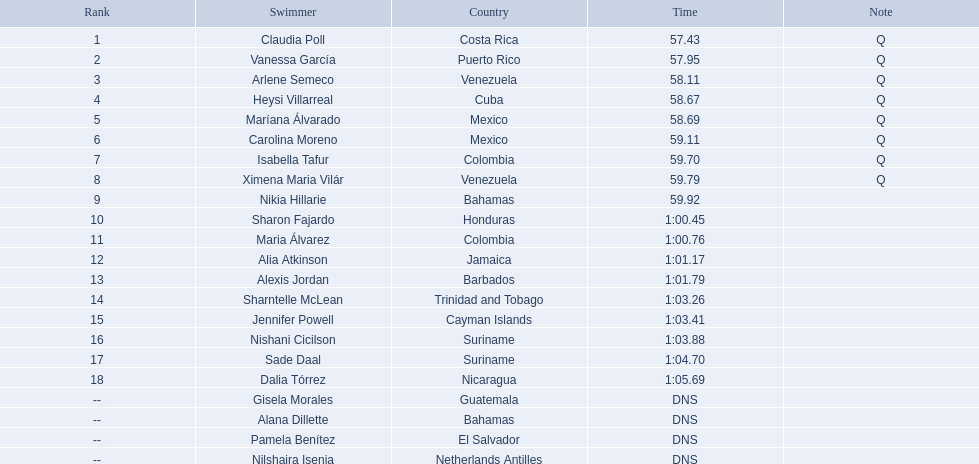Where did the top eight competitors come from? Costa Rica, Puerto Rico, Venezuela, Cuba, Mexico, Mexico, Colombia, Venezuela. Which among the top eight originated from cuba? Heysi Villarreal. 